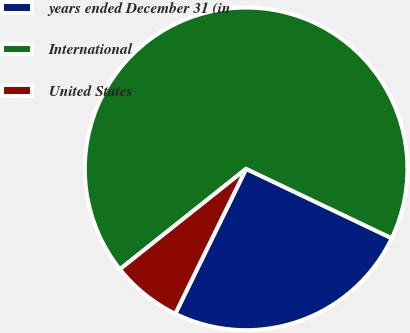<chart> <loc_0><loc_0><loc_500><loc_500><pie_chart><fcel>years ended December 31 (in<fcel>International<fcel>United States<nl><fcel>25.16%<fcel>67.77%<fcel>7.07%<nl></chart> 